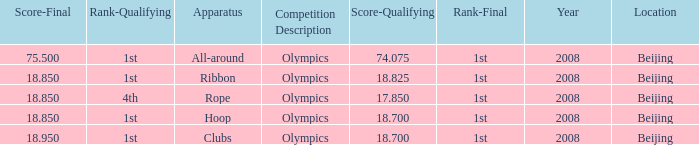What was her final score on the ribbon apparatus? 18.85. 